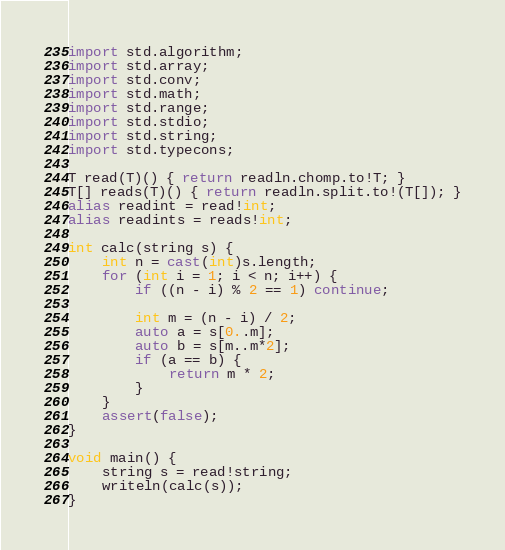<code> <loc_0><loc_0><loc_500><loc_500><_D_>import std.algorithm;
import std.array;
import std.conv;
import std.math;
import std.range;
import std.stdio;
import std.string;
import std.typecons;

T read(T)() { return readln.chomp.to!T; }
T[] reads(T)() { return readln.split.to!(T[]); }
alias readint = read!int;
alias readints = reads!int;

int calc(string s) {
    int n = cast(int)s.length;
    for (int i = 1; i < n; i++) {
        if ((n - i) % 2 == 1) continue;

        int m = (n - i) / 2;
        auto a = s[0..m];
        auto b = s[m..m*2];
        if (a == b) {
            return m * 2;
        }
    }
    assert(false);
}

void main() {
    string s = read!string;
    writeln(calc(s));
}
</code> 